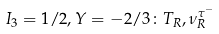Convert formula to latex. <formula><loc_0><loc_0><loc_500><loc_500>I _ { 3 } = 1 / 2 , Y = - 2 / 3 \colon T _ { R } , \nu ^ { \tau ^ { - } } _ { R }</formula> 